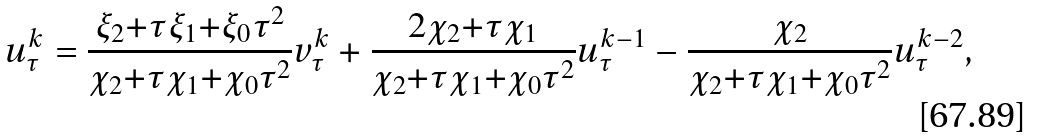Convert formula to latex. <formula><loc_0><loc_0><loc_500><loc_500>u _ { \tau } ^ { k } = \frac { \xi _ { 2 } { + } \tau \xi _ { 1 } { + } \xi _ { 0 } \tau ^ { 2 } } { \chi _ { 2 } { + } \tau \chi _ { 1 } { + } \chi _ { 0 } \tau ^ { 2 } } v _ { \tau } ^ { k } + \frac { 2 \chi _ { 2 } { + } \tau \chi _ { 1 } } { \chi _ { 2 } { + } \tau \chi _ { 1 } { + } \chi _ { 0 } \tau ^ { 2 } } u _ { \tau } ^ { k - 1 } - \frac { \chi _ { 2 } } { \chi _ { 2 } { + } \tau \chi _ { 1 } { + } \chi _ { 0 } \tau ^ { 2 } } u _ { \tau } ^ { k - 2 } ,</formula> 